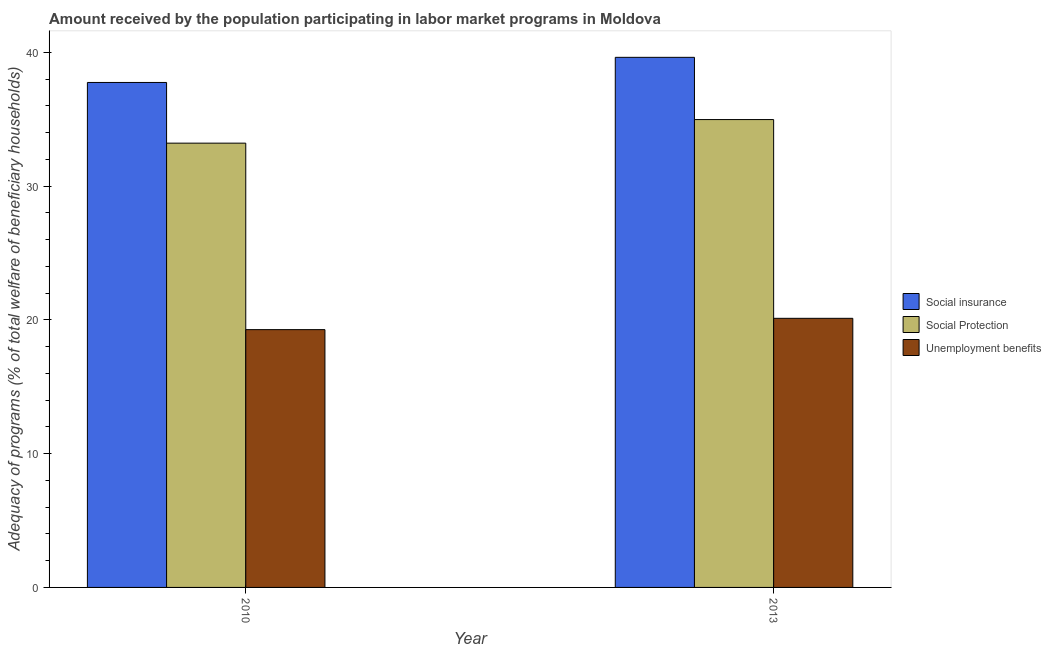How many different coloured bars are there?
Provide a short and direct response. 3. Are the number of bars per tick equal to the number of legend labels?
Give a very brief answer. Yes. How many bars are there on the 2nd tick from the left?
Your response must be concise. 3. What is the label of the 2nd group of bars from the left?
Give a very brief answer. 2013. What is the amount received by the population participating in social insurance programs in 2013?
Provide a short and direct response. 39.64. Across all years, what is the maximum amount received by the population participating in social protection programs?
Ensure brevity in your answer.  34.98. Across all years, what is the minimum amount received by the population participating in social protection programs?
Offer a very short reply. 33.22. What is the total amount received by the population participating in social insurance programs in the graph?
Your answer should be compact. 77.4. What is the difference between the amount received by the population participating in social insurance programs in 2010 and that in 2013?
Provide a short and direct response. -1.88. What is the difference between the amount received by the population participating in social protection programs in 2010 and the amount received by the population participating in social insurance programs in 2013?
Keep it short and to the point. -1.76. What is the average amount received by the population participating in unemployment benefits programs per year?
Offer a very short reply. 19.7. What is the ratio of the amount received by the population participating in unemployment benefits programs in 2010 to that in 2013?
Make the answer very short. 0.96. In how many years, is the amount received by the population participating in unemployment benefits programs greater than the average amount received by the population participating in unemployment benefits programs taken over all years?
Give a very brief answer. 1. What does the 1st bar from the left in 2013 represents?
Make the answer very short. Social insurance. What does the 1st bar from the right in 2013 represents?
Provide a short and direct response. Unemployment benefits. Is it the case that in every year, the sum of the amount received by the population participating in social insurance programs and amount received by the population participating in social protection programs is greater than the amount received by the population participating in unemployment benefits programs?
Make the answer very short. Yes. Are all the bars in the graph horizontal?
Your answer should be compact. No. Are the values on the major ticks of Y-axis written in scientific E-notation?
Your answer should be very brief. No. Does the graph contain grids?
Ensure brevity in your answer.  No. How many legend labels are there?
Your answer should be very brief. 3. What is the title of the graph?
Offer a terse response. Amount received by the population participating in labor market programs in Moldova. What is the label or title of the Y-axis?
Offer a very short reply. Adequacy of programs (% of total welfare of beneficiary households). What is the Adequacy of programs (% of total welfare of beneficiary households) of Social insurance in 2010?
Your answer should be compact. 37.76. What is the Adequacy of programs (% of total welfare of beneficiary households) in Social Protection in 2010?
Your answer should be very brief. 33.22. What is the Adequacy of programs (% of total welfare of beneficiary households) of Unemployment benefits in 2010?
Keep it short and to the point. 19.28. What is the Adequacy of programs (% of total welfare of beneficiary households) of Social insurance in 2013?
Your answer should be compact. 39.64. What is the Adequacy of programs (% of total welfare of beneficiary households) in Social Protection in 2013?
Your response must be concise. 34.98. What is the Adequacy of programs (% of total welfare of beneficiary households) of Unemployment benefits in 2013?
Your answer should be very brief. 20.12. Across all years, what is the maximum Adequacy of programs (% of total welfare of beneficiary households) of Social insurance?
Provide a short and direct response. 39.64. Across all years, what is the maximum Adequacy of programs (% of total welfare of beneficiary households) in Social Protection?
Your answer should be very brief. 34.98. Across all years, what is the maximum Adequacy of programs (% of total welfare of beneficiary households) in Unemployment benefits?
Offer a terse response. 20.12. Across all years, what is the minimum Adequacy of programs (% of total welfare of beneficiary households) of Social insurance?
Your answer should be very brief. 37.76. Across all years, what is the minimum Adequacy of programs (% of total welfare of beneficiary households) in Social Protection?
Give a very brief answer. 33.22. Across all years, what is the minimum Adequacy of programs (% of total welfare of beneficiary households) of Unemployment benefits?
Ensure brevity in your answer.  19.28. What is the total Adequacy of programs (% of total welfare of beneficiary households) of Social insurance in the graph?
Offer a very short reply. 77.4. What is the total Adequacy of programs (% of total welfare of beneficiary households) in Social Protection in the graph?
Offer a terse response. 68.21. What is the total Adequacy of programs (% of total welfare of beneficiary households) in Unemployment benefits in the graph?
Provide a succinct answer. 39.4. What is the difference between the Adequacy of programs (% of total welfare of beneficiary households) in Social insurance in 2010 and that in 2013?
Give a very brief answer. -1.88. What is the difference between the Adequacy of programs (% of total welfare of beneficiary households) in Social Protection in 2010 and that in 2013?
Provide a short and direct response. -1.76. What is the difference between the Adequacy of programs (% of total welfare of beneficiary households) of Unemployment benefits in 2010 and that in 2013?
Provide a succinct answer. -0.85. What is the difference between the Adequacy of programs (% of total welfare of beneficiary households) in Social insurance in 2010 and the Adequacy of programs (% of total welfare of beneficiary households) in Social Protection in 2013?
Provide a short and direct response. 2.78. What is the difference between the Adequacy of programs (% of total welfare of beneficiary households) of Social insurance in 2010 and the Adequacy of programs (% of total welfare of beneficiary households) of Unemployment benefits in 2013?
Provide a short and direct response. 17.64. What is the difference between the Adequacy of programs (% of total welfare of beneficiary households) of Social Protection in 2010 and the Adequacy of programs (% of total welfare of beneficiary households) of Unemployment benefits in 2013?
Provide a short and direct response. 13.1. What is the average Adequacy of programs (% of total welfare of beneficiary households) of Social insurance per year?
Your answer should be compact. 38.7. What is the average Adequacy of programs (% of total welfare of beneficiary households) of Social Protection per year?
Give a very brief answer. 34.1. What is the average Adequacy of programs (% of total welfare of beneficiary households) in Unemployment benefits per year?
Keep it short and to the point. 19.7. In the year 2010, what is the difference between the Adequacy of programs (% of total welfare of beneficiary households) of Social insurance and Adequacy of programs (% of total welfare of beneficiary households) of Social Protection?
Give a very brief answer. 4.54. In the year 2010, what is the difference between the Adequacy of programs (% of total welfare of beneficiary households) in Social insurance and Adequacy of programs (% of total welfare of beneficiary households) in Unemployment benefits?
Keep it short and to the point. 18.48. In the year 2010, what is the difference between the Adequacy of programs (% of total welfare of beneficiary households) of Social Protection and Adequacy of programs (% of total welfare of beneficiary households) of Unemployment benefits?
Offer a very short reply. 13.95. In the year 2013, what is the difference between the Adequacy of programs (% of total welfare of beneficiary households) in Social insurance and Adequacy of programs (% of total welfare of beneficiary households) in Social Protection?
Ensure brevity in your answer.  4.65. In the year 2013, what is the difference between the Adequacy of programs (% of total welfare of beneficiary households) in Social insurance and Adequacy of programs (% of total welfare of beneficiary households) in Unemployment benefits?
Your answer should be very brief. 19.52. In the year 2013, what is the difference between the Adequacy of programs (% of total welfare of beneficiary households) in Social Protection and Adequacy of programs (% of total welfare of beneficiary households) in Unemployment benefits?
Your response must be concise. 14.86. What is the ratio of the Adequacy of programs (% of total welfare of beneficiary households) of Social insurance in 2010 to that in 2013?
Provide a short and direct response. 0.95. What is the ratio of the Adequacy of programs (% of total welfare of beneficiary households) in Social Protection in 2010 to that in 2013?
Keep it short and to the point. 0.95. What is the ratio of the Adequacy of programs (% of total welfare of beneficiary households) in Unemployment benefits in 2010 to that in 2013?
Give a very brief answer. 0.96. What is the difference between the highest and the second highest Adequacy of programs (% of total welfare of beneficiary households) of Social insurance?
Ensure brevity in your answer.  1.88. What is the difference between the highest and the second highest Adequacy of programs (% of total welfare of beneficiary households) of Social Protection?
Give a very brief answer. 1.76. What is the difference between the highest and the second highest Adequacy of programs (% of total welfare of beneficiary households) of Unemployment benefits?
Keep it short and to the point. 0.85. What is the difference between the highest and the lowest Adequacy of programs (% of total welfare of beneficiary households) in Social insurance?
Offer a very short reply. 1.88. What is the difference between the highest and the lowest Adequacy of programs (% of total welfare of beneficiary households) of Social Protection?
Ensure brevity in your answer.  1.76. What is the difference between the highest and the lowest Adequacy of programs (% of total welfare of beneficiary households) in Unemployment benefits?
Ensure brevity in your answer.  0.85. 